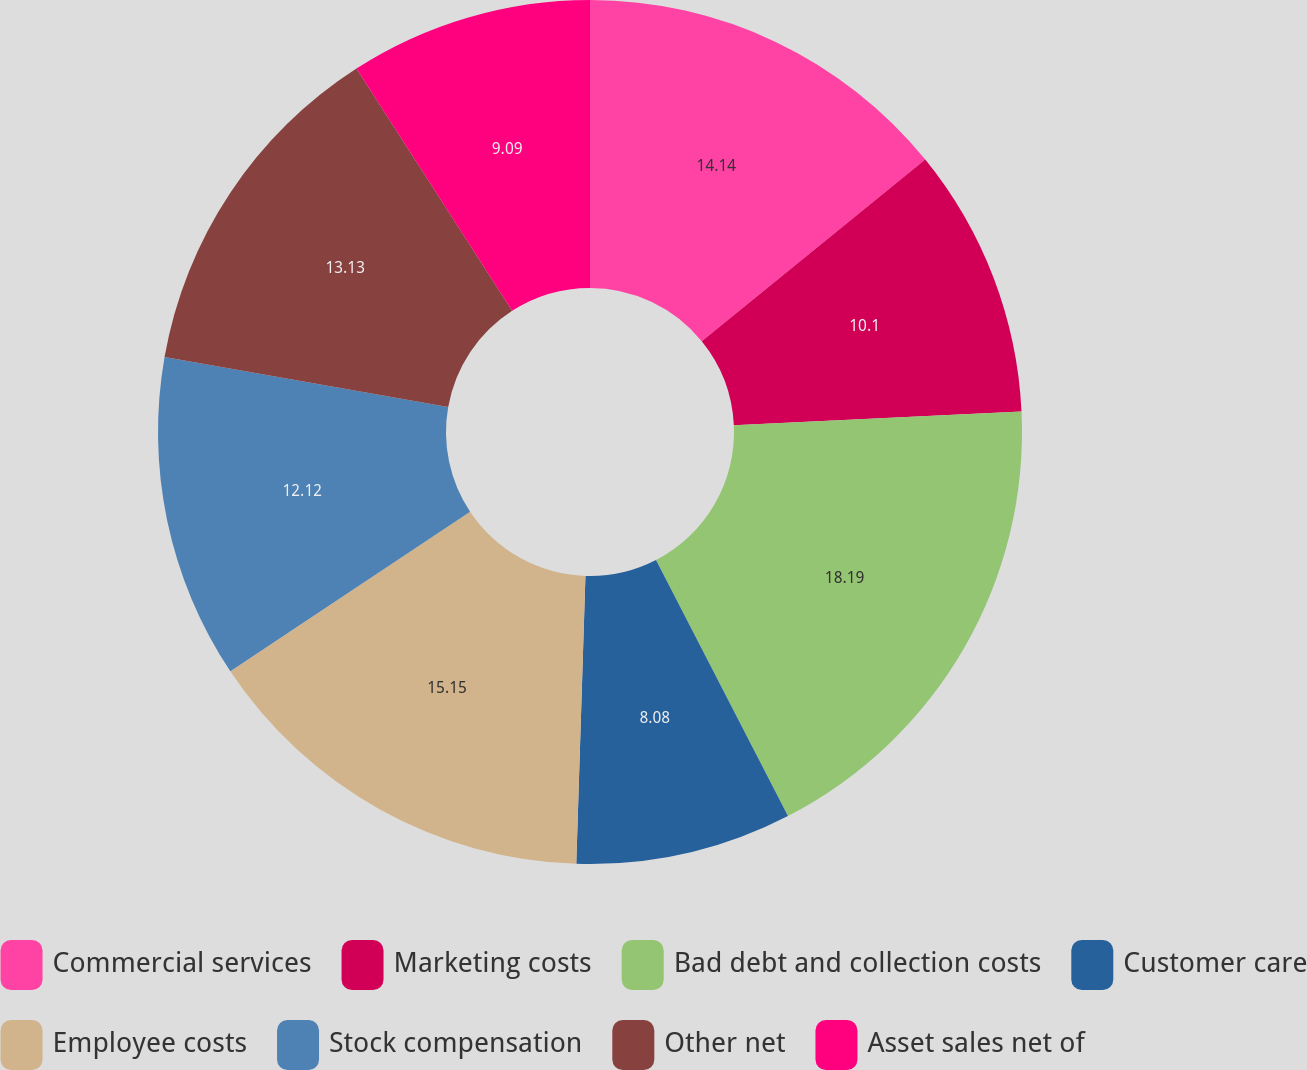<chart> <loc_0><loc_0><loc_500><loc_500><pie_chart><fcel>Commercial services<fcel>Marketing costs<fcel>Bad debt and collection costs<fcel>Customer care<fcel>Employee costs<fcel>Stock compensation<fcel>Other net<fcel>Asset sales net of<nl><fcel>14.14%<fcel>10.1%<fcel>18.18%<fcel>8.08%<fcel>15.15%<fcel>12.12%<fcel>13.13%<fcel>9.09%<nl></chart> 